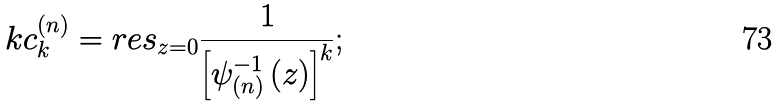<formula> <loc_0><loc_0><loc_500><loc_500>k c _ { k } ^ { \left ( n \right ) } = r e s _ { z = 0 } \frac { 1 } { \left [ \psi _ { \left ( n \right ) } ^ { - 1 } \left ( z \right ) \right ] ^ { k } } ;</formula> 